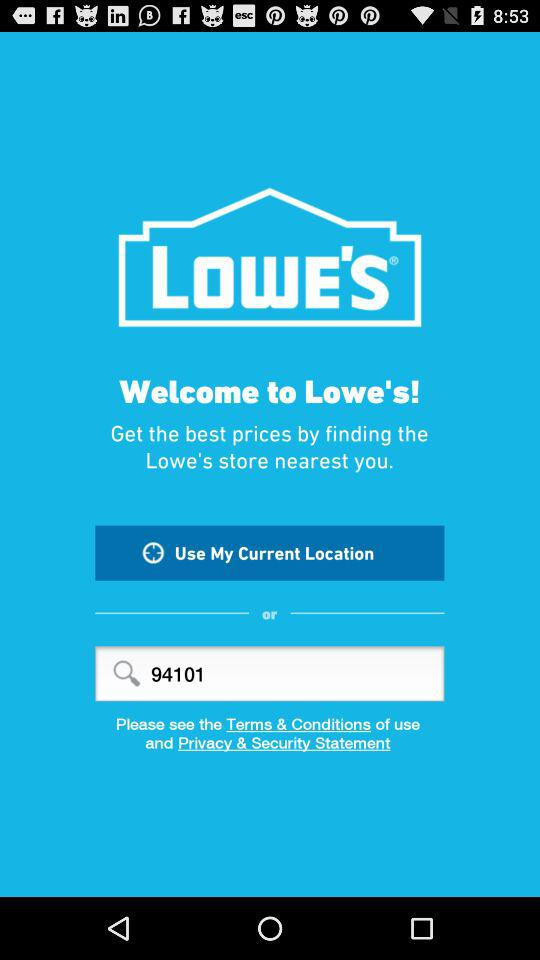What is the given pincode? The given pincode is 94101. 